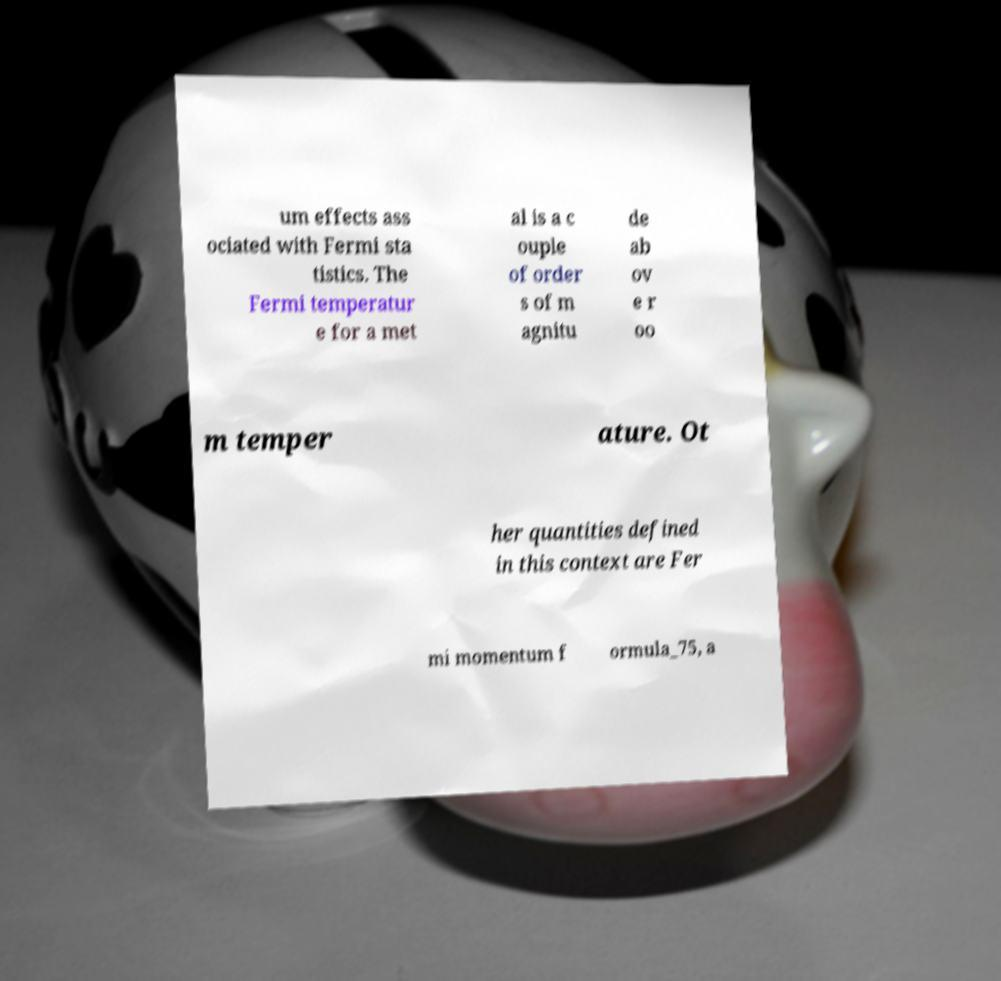Could you extract and type out the text from this image? um effects ass ociated with Fermi sta tistics. The Fermi temperatur e for a met al is a c ouple of order s of m agnitu de ab ov e r oo m temper ature. Ot her quantities defined in this context are Fer mi momentum f ormula_75, a 